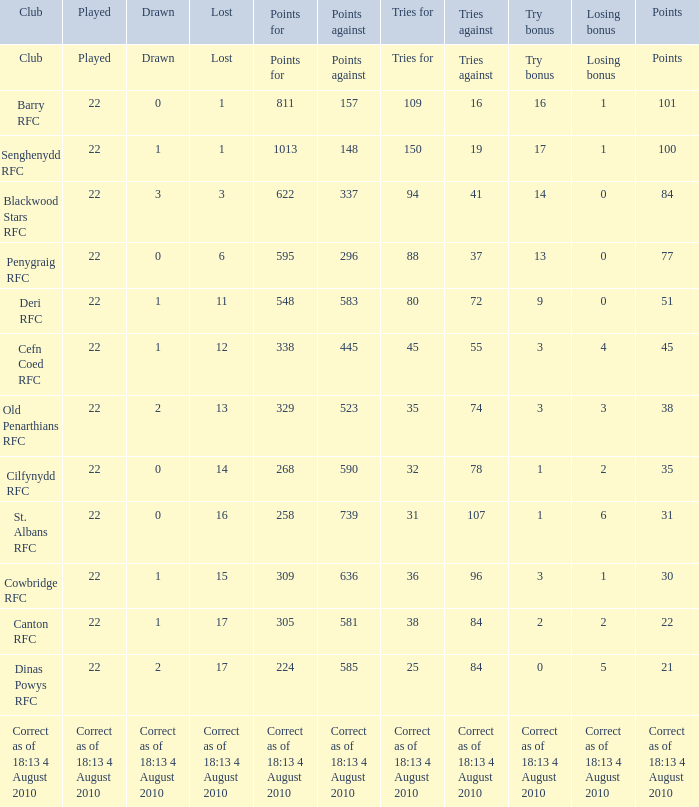What is the tally when the defeat was 11? 548.0. 